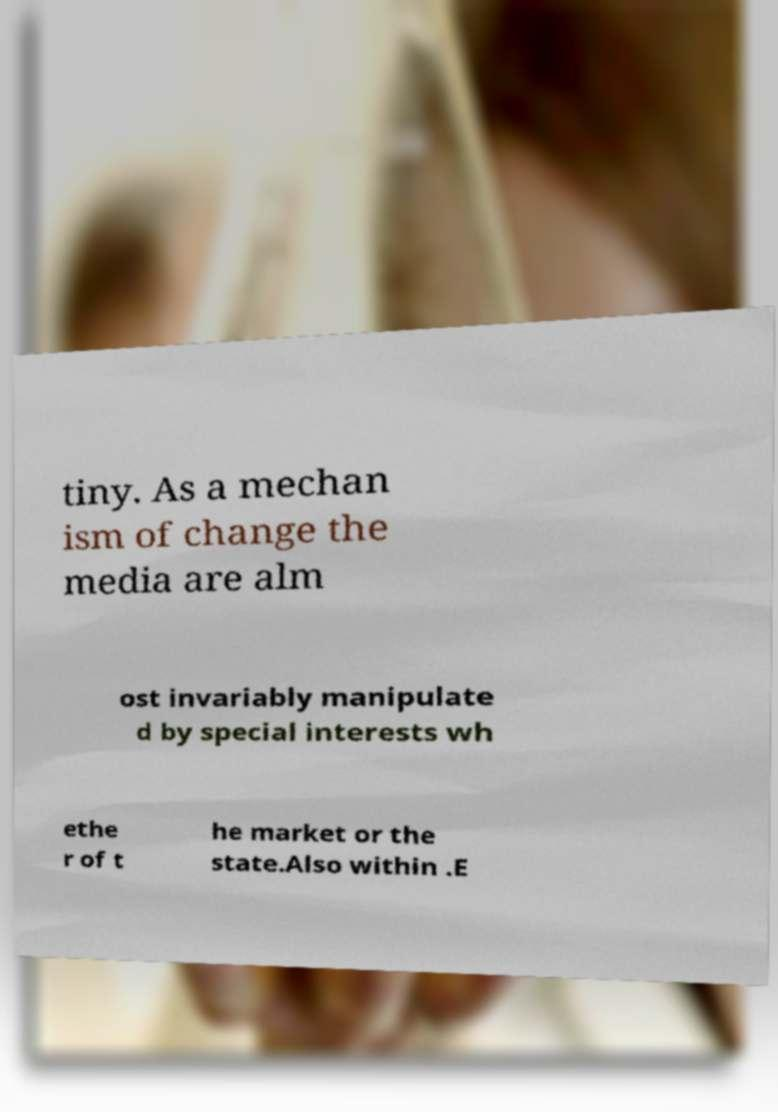For documentation purposes, I need the text within this image transcribed. Could you provide that? tiny. As a mechan ism of change the media are alm ost invariably manipulate d by special interests wh ethe r of t he market or the state.Also within .E 